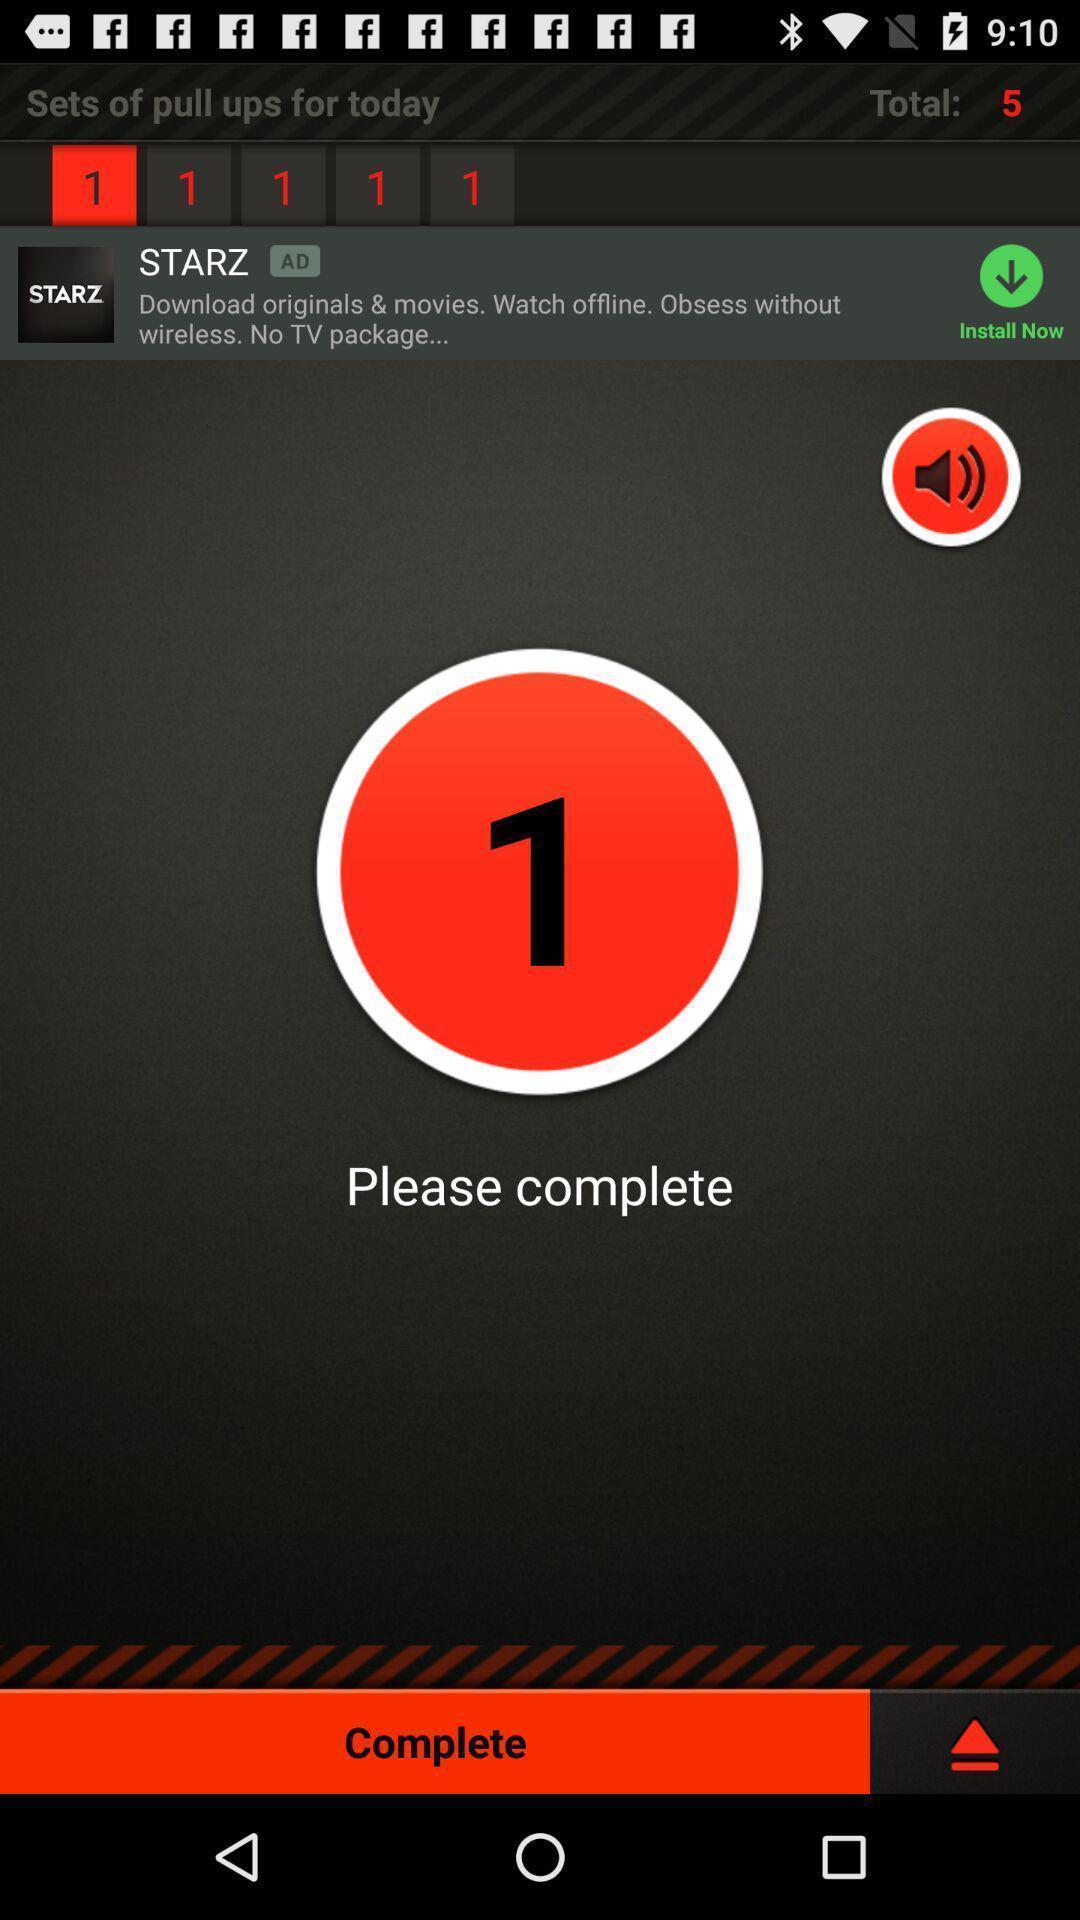Give me a summary of this screen capture. Screen displaying timer to complete action. 